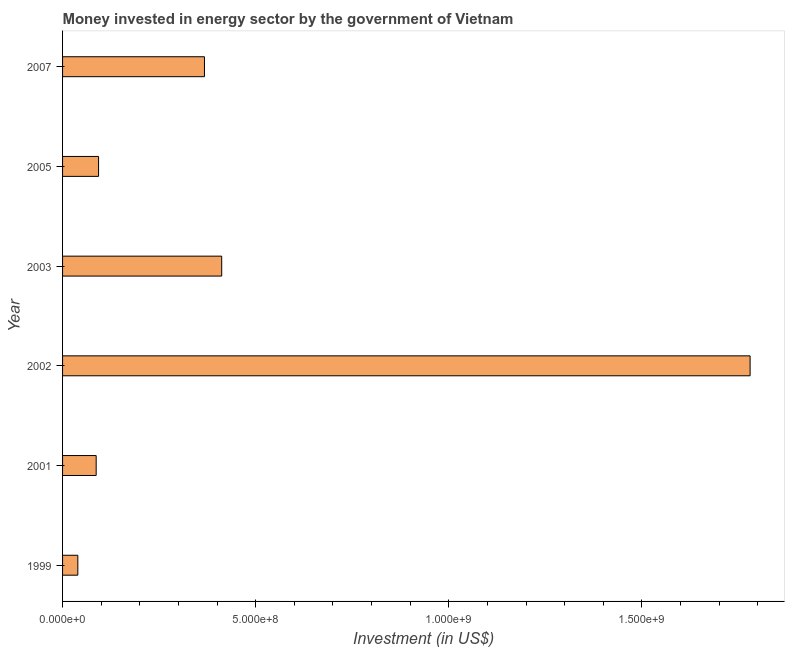Does the graph contain grids?
Provide a short and direct response. No. What is the title of the graph?
Offer a terse response. Money invested in energy sector by the government of Vietnam. What is the label or title of the X-axis?
Provide a short and direct response. Investment (in US$). What is the label or title of the Y-axis?
Your answer should be compact. Year. What is the investment in energy in 2003?
Offer a terse response. 4.12e+08. Across all years, what is the maximum investment in energy?
Provide a short and direct response. 1.78e+09. Across all years, what is the minimum investment in energy?
Provide a short and direct response. 3.95e+07. In which year was the investment in energy maximum?
Your answer should be compact. 2002. In which year was the investment in energy minimum?
Make the answer very short. 1999. What is the sum of the investment in energy?
Provide a succinct answer. 2.78e+09. What is the difference between the investment in energy in 1999 and 2005?
Offer a very short reply. -5.37e+07. What is the average investment in energy per year?
Make the answer very short. 4.63e+08. What is the median investment in energy?
Keep it short and to the point. 2.30e+08. What is the ratio of the investment in energy in 2005 to that in 2007?
Ensure brevity in your answer.  0.25. What is the difference between the highest and the second highest investment in energy?
Provide a succinct answer. 1.37e+09. Is the sum of the investment in energy in 1999 and 2003 greater than the maximum investment in energy across all years?
Give a very brief answer. No. What is the difference between the highest and the lowest investment in energy?
Provide a short and direct response. 1.74e+09. In how many years, is the investment in energy greater than the average investment in energy taken over all years?
Provide a short and direct response. 1. Are all the bars in the graph horizontal?
Give a very brief answer. Yes. What is the difference between two consecutive major ticks on the X-axis?
Offer a very short reply. 5.00e+08. What is the Investment (in US$) in 1999?
Offer a terse response. 3.95e+07. What is the Investment (in US$) in 2001?
Your answer should be compact. 8.70e+07. What is the Investment (in US$) of 2002?
Your answer should be compact. 1.78e+09. What is the Investment (in US$) in 2003?
Keep it short and to the point. 4.12e+08. What is the Investment (in US$) in 2005?
Your answer should be compact. 9.32e+07. What is the Investment (in US$) in 2007?
Give a very brief answer. 3.67e+08. What is the difference between the Investment (in US$) in 1999 and 2001?
Ensure brevity in your answer.  -4.75e+07. What is the difference between the Investment (in US$) in 1999 and 2002?
Your response must be concise. -1.74e+09. What is the difference between the Investment (in US$) in 1999 and 2003?
Keep it short and to the point. -3.72e+08. What is the difference between the Investment (in US$) in 1999 and 2005?
Provide a short and direct response. -5.37e+07. What is the difference between the Investment (in US$) in 1999 and 2007?
Provide a succinct answer. -3.28e+08. What is the difference between the Investment (in US$) in 2001 and 2002?
Provide a succinct answer. -1.69e+09. What is the difference between the Investment (in US$) in 2001 and 2003?
Keep it short and to the point. -3.25e+08. What is the difference between the Investment (in US$) in 2001 and 2005?
Offer a terse response. -6.20e+06. What is the difference between the Investment (in US$) in 2001 and 2007?
Give a very brief answer. -2.80e+08. What is the difference between the Investment (in US$) in 2002 and 2003?
Ensure brevity in your answer.  1.37e+09. What is the difference between the Investment (in US$) in 2002 and 2005?
Keep it short and to the point. 1.69e+09. What is the difference between the Investment (in US$) in 2002 and 2007?
Make the answer very short. 1.41e+09. What is the difference between the Investment (in US$) in 2003 and 2005?
Offer a very short reply. 3.19e+08. What is the difference between the Investment (in US$) in 2003 and 2007?
Give a very brief answer. 4.46e+07. What is the difference between the Investment (in US$) in 2005 and 2007?
Your answer should be compact. -2.74e+08. What is the ratio of the Investment (in US$) in 1999 to that in 2001?
Keep it short and to the point. 0.45. What is the ratio of the Investment (in US$) in 1999 to that in 2002?
Provide a succinct answer. 0.02. What is the ratio of the Investment (in US$) in 1999 to that in 2003?
Give a very brief answer. 0.1. What is the ratio of the Investment (in US$) in 1999 to that in 2005?
Make the answer very short. 0.42. What is the ratio of the Investment (in US$) in 1999 to that in 2007?
Keep it short and to the point. 0.11. What is the ratio of the Investment (in US$) in 2001 to that in 2002?
Your answer should be compact. 0.05. What is the ratio of the Investment (in US$) in 2001 to that in 2003?
Make the answer very short. 0.21. What is the ratio of the Investment (in US$) in 2001 to that in 2005?
Your answer should be compact. 0.93. What is the ratio of the Investment (in US$) in 2001 to that in 2007?
Offer a very short reply. 0.24. What is the ratio of the Investment (in US$) in 2002 to that in 2003?
Offer a very short reply. 4.32. What is the ratio of the Investment (in US$) in 2002 to that in 2005?
Your answer should be compact. 19.1. What is the ratio of the Investment (in US$) in 2002 to that in 2007?
Your answer should be compact. 4.84. What is the ratio of the Investment (in US$) in 2003 to that in 2005?
Keep it short and to the point. 4.42. What is the ratio of the Investment (in US$) in 2003 to that in 2007?
Give a very brief answer. 1.12. What is the ratio of the Investment (in US$) in 2005 to that in 2007?
Provide a succinct answer. 0.25. 